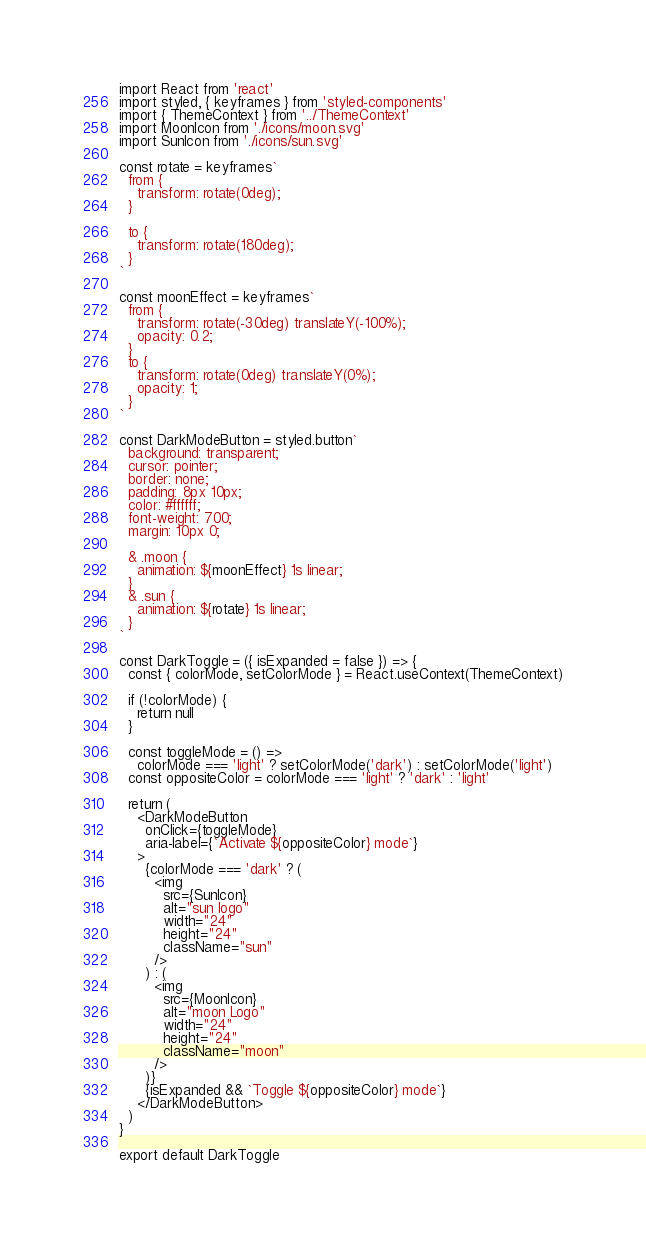<code> <loc_0><loc_0><loc_500><loc_500><_JavaScript_>import React from 'react'
import styled, { keyframes } from 'styled-components'
import { ThemeContext } from '../ThemeContext'
import MoonIcon from './icons/moon.svg'
import SunIcon from './icons/sun.svg'

const rotate = keyframes`
  from {
    transform: rotate(0deg);
  }

  to {
    transform: rotate(180deg);
  }
`

const moonEffect = keyframes`
  from {
    transform: rotate(-30deg) translateY(-100%);
    opacity: 0.2;
  }
  to {
    transform: rotate(0deg) translateY(0%);
    opacity: 1;
  }
`

const DarkModeButton = styled.button`
  background: transparent;
  cursor: pointer;
  border: none;
  padding: 8px 10px;
  color: #ffffff;
  font-weight: 700;
  margin: 10px 0;

  & .moon {
    animation: ${moonEffect} 1s linear;
  }
  & .sun {
    animation: ${rotate} 1s linear;
  }
`

const DarkToggle = ({ isExpanded = false }) => {
  const { colorMode, setColorMode } = React.useContext(ThemeContext)

  if (!colorMode) {
    return null
  }

  const toggleMode = () =>
    colorMode === 'light' ? setColorMode('dark') : setColorMode('light')
  const oppositeColor = colorMode === 'light' ? 'dark' : 'light'

  return (
    <DarkModeButton
      onClick={toggleMode}
      aria-label={`Activate ${oppositeColor} mode`}
    >
      {colorMode === 'dark' ? (
        <img
          src={SunIcon}
          alt="sun logo"
          width="24"
          height="24"
          className="sun"
        />
      ) : (
        <img
          src={MoonIcon}
          alt="moon Logo"
          width="24"
          height="24"
          className="moon"
        />
      )}
      {isExpanded && `Toggle ${oppositeColor} mode`}
    </DarkModeButton>
  )
}

export default DarkToggle
</code> 